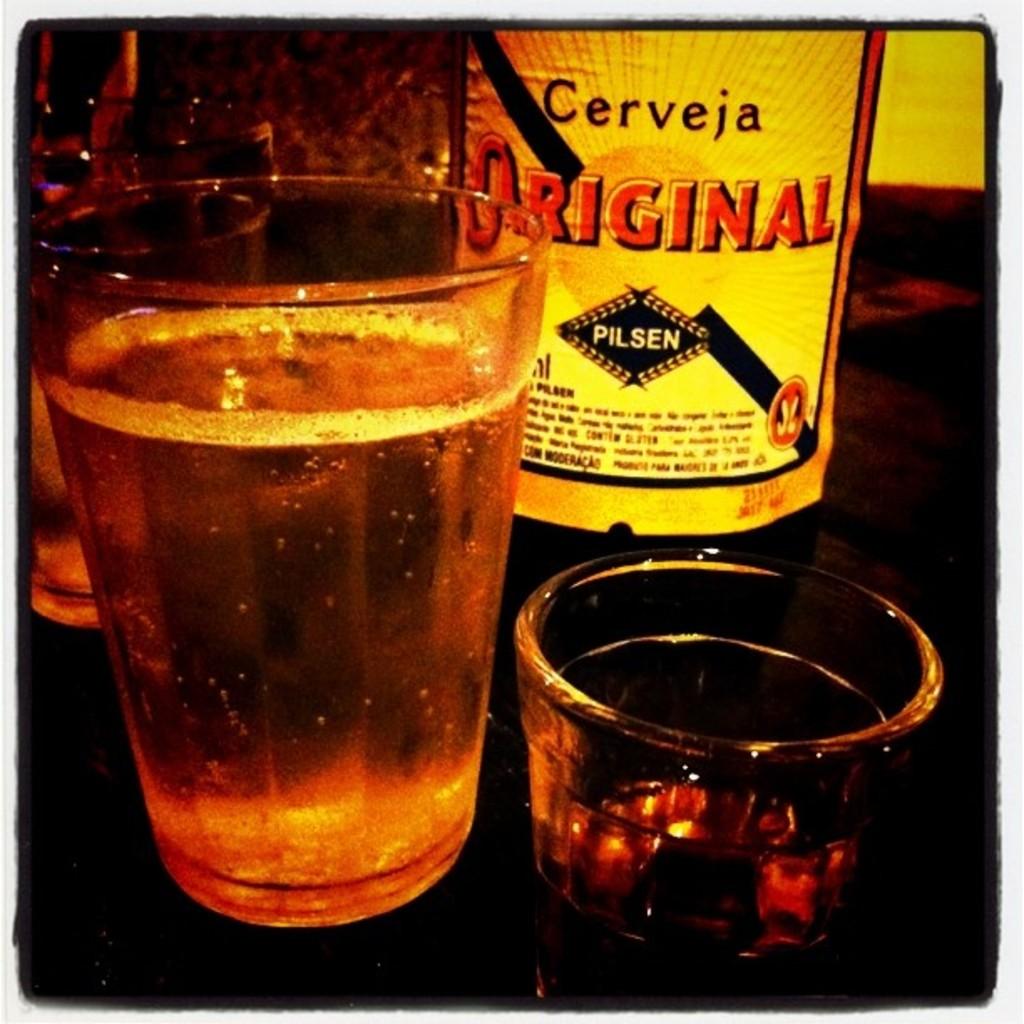What is the name of this beer?
Provide a succinct answer. Cerveja original. What type of drink is this?
Give a very brief answer. Beer. 